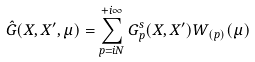Convert formula to latex. <formula><loc_0><loc_0><loc_500><loc_500>\hat { G } ( X , X ^ { \prime } , \mu ) = \sum ^ { + i \infty } _ { p = i N } G ^ { s } _ { p } ( X , X ^ { \prime } ) W _ { ( p ) } ( \mu )</formula> 